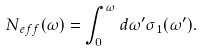<formula> <loc_0><loc_0><loc_500><loc_500>N _ { e f f } ( \omega ) = \int _ { 0 } ^ { \omega } d \omega ^ { \prime } \sigma _ { 1 } ( \omega ^ { \prime } ) .</formula> 